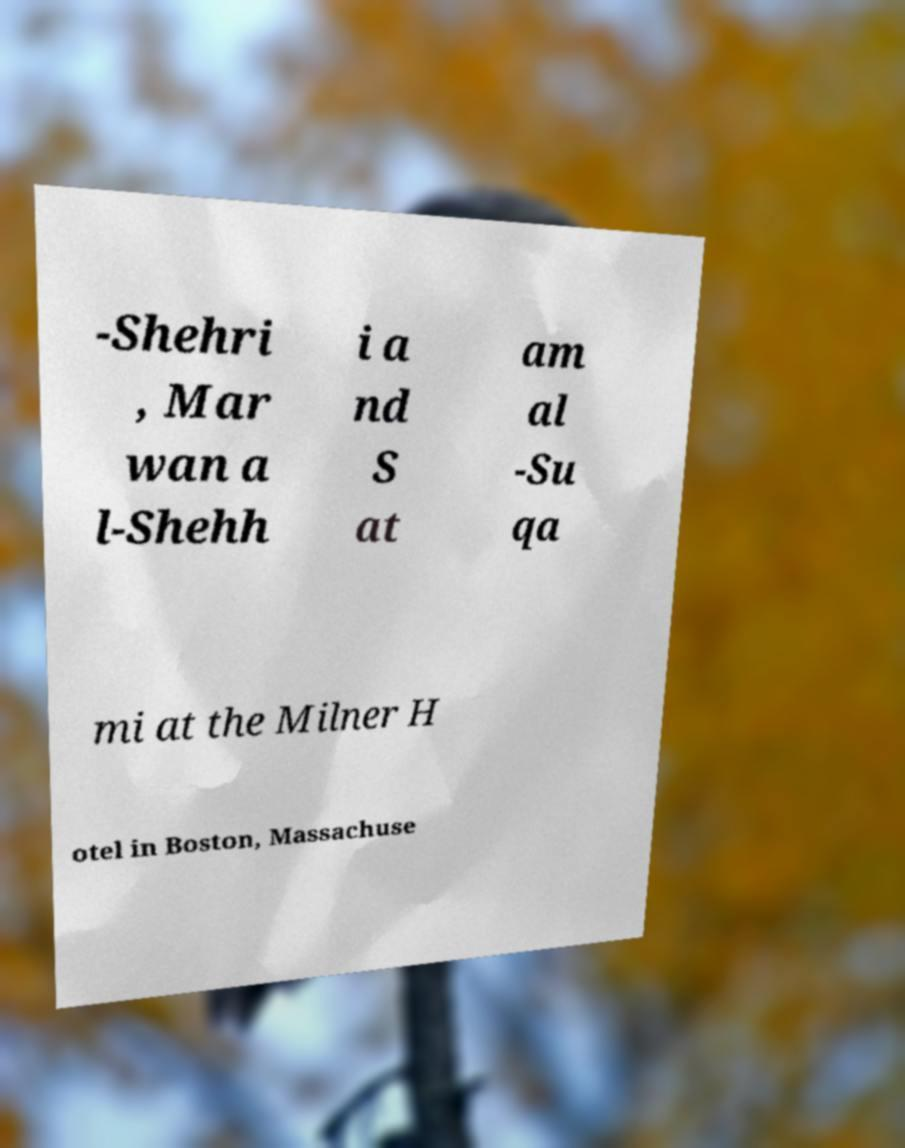Can you read and provide the text displayed in the image?This photo seems to have some interesting text. Can you extract and type it out for me? -Shehri , Mar wan a l-Shehh i a nd S at am al -Su qa mi at the Milner H otel in Boston, Massachuse 